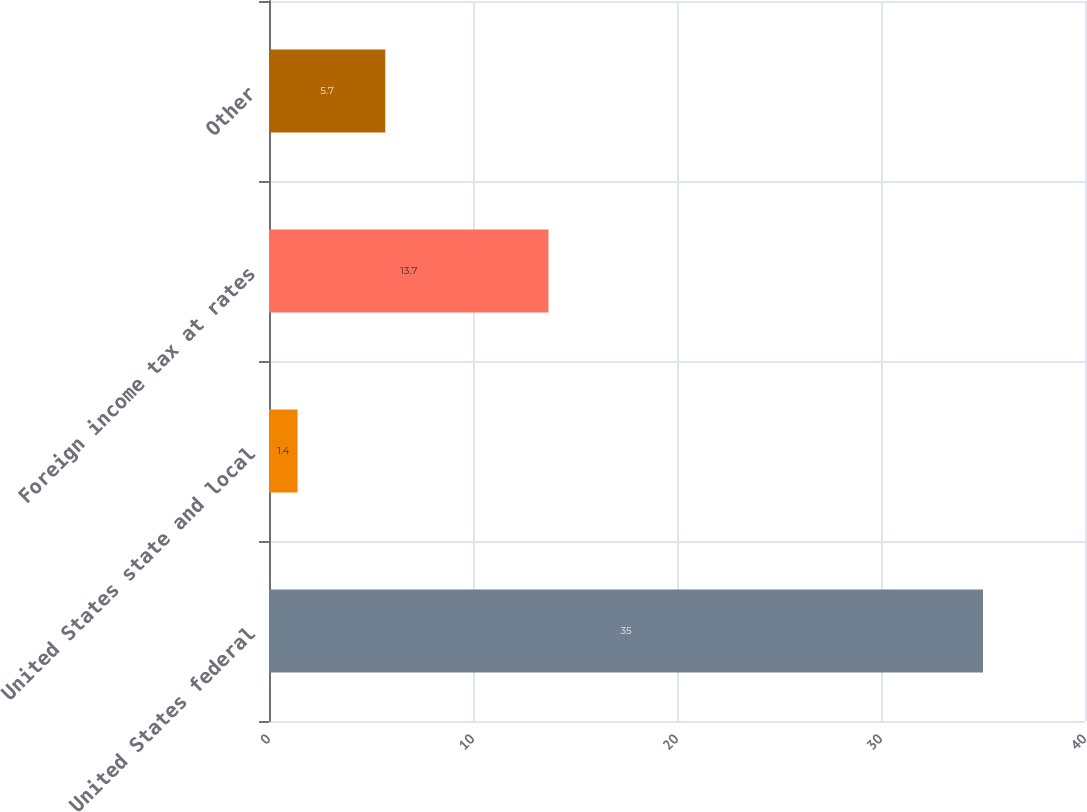Convert chart to OTSL. <chart><loc_0><loc_0><loc_500><loc_500><bar_chart><fcel>United States federal<fcel>United States state and local<fcel>Foreign income tax at rates<fcel>Other<nl><fcel>35<fcel>1.4<fcel>13.7<fcel>5.7<nl></chart> 